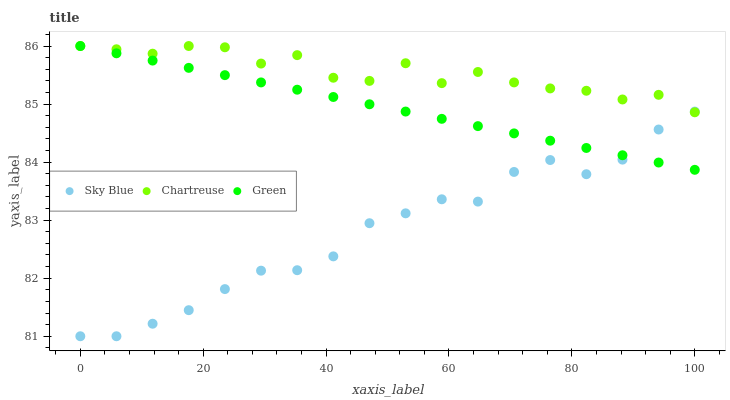Does Sky Blue have the minimum area under the curve?
Answer yes or no. Yes. Does Chartreuse have the maximum area under the curve?
Answer yes or no. Yes. Does Green have the minimum area under the curve?
Answer yes or no. No. Does Green have the maximum area under the curve?
Answer yes or no. No. Is Green the smoothest?
Answer yes or no. Yes. Is Chartreuse the roughest?
Answer yes or no. Yes. Is Chartreuse the smoothest?
Answer yes or no. No. Is Green the roughest?
Answer yes or no. No. Does Sky Blue have the lowest value?
Answer yes or no. Yes. Does Green have the lowest value?
Answer yes or no. No. Does Green have the highest value?
Answer yes or no. Yes. Does Green intersect Chartreuse?
Answer yes or no. Yes. Is Green less than Chartreuse?
Answer yes or no. No. Is Green greater than Chartreuse?
Answer yes or no. No. 